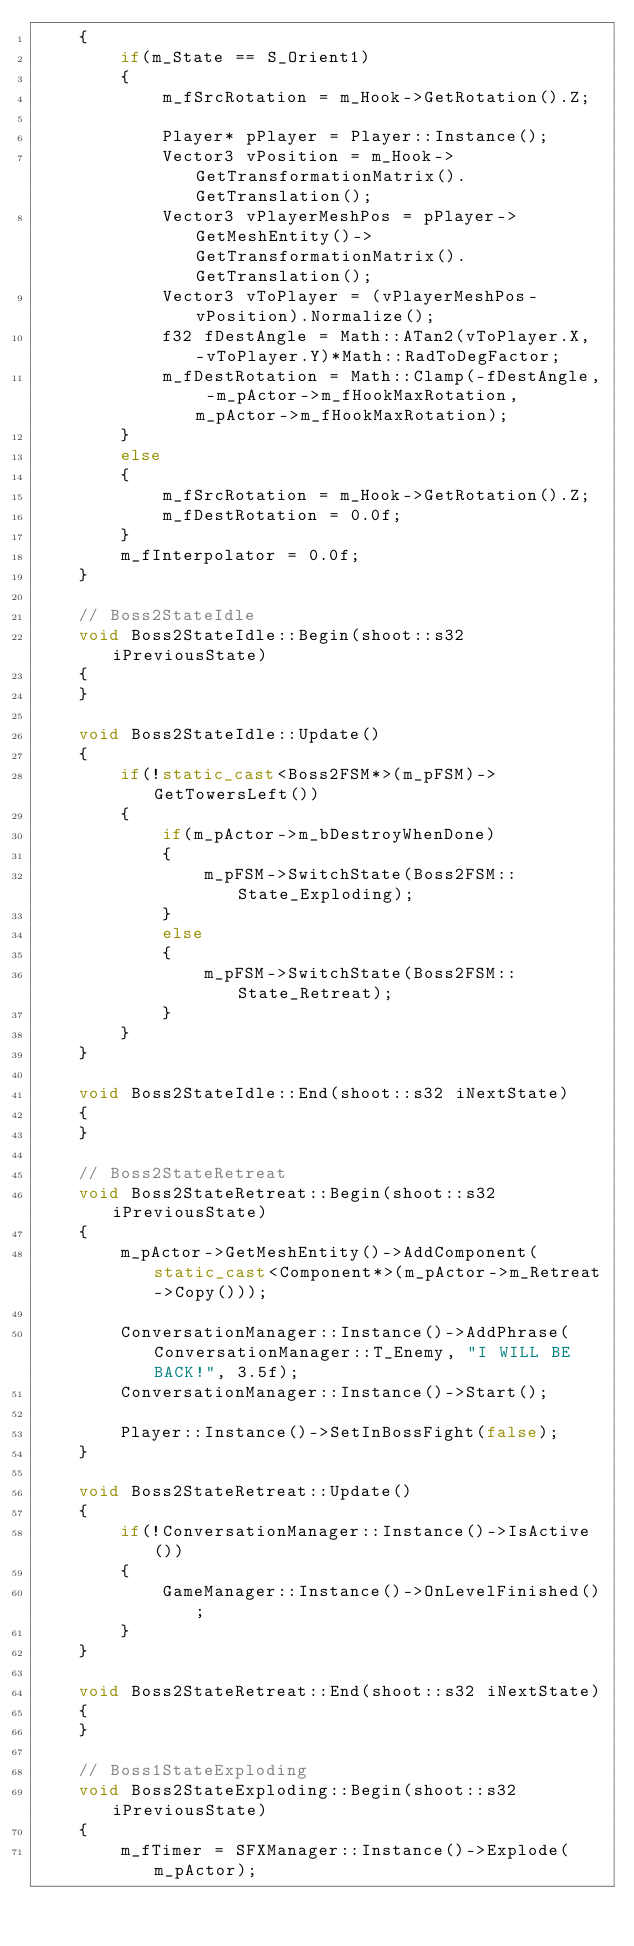Convert code to text. <code><loc_0><loc_0><loc_500><loc_500><_C++_>	{
		if(m_State == S_Orient1)
		{
			m_fSrcRotation = m_Hook->GetRotation().Z;

			Player* pPlayer = Player::Instance();
			Vector3 vPosition = m_Hook->GetTransformationMatrix().GetTranslation();			
			Vector3 vPlayerMeshPos = pPlayer->GetMeshEntity()->GetTransformationMatrix().GetTranslation();
			Vector3 vToPlayer = (vPlayerMeshPos-vPosition).Normalize();			
			f32 fDestAngle = Math::ATan2(vToPlayer.X, -vToPlayer.Y)*Math::RadToDegFactor;
			m_fDestRotation = Math::Clamp(-fDestAngle, -m_pActor->m_fHookMaxRotation, m_pActor->m_fHookMaxRotation);
		}
		else
		{
			m_fSrcRotation = m_Hook->GetRotation().Z;
			m_fDestRotation = 0.0f;
		}
		m_fInterpolator = 0.0f;
	}

	// Boss2StateIdle
	void Boss2StateIdle::Begin(shoot::s32 iPreviousState)
	{
	}

	void Boss2StateIdle::Update()
	{
		if(!static_cast<Boss2FSM*>(m_pFSM)->GetTowersLeft())
		{
			if(m_pActor->m_bDestroyWhenDone)
			{
				m_pFSM->SwitchState(Boss2FSM::State_Exploding);
			}
			else
			{
				m_pFSM->SwitchState(Boss2FSM::State_Retreat);
			}			
		}
	}

	void Boss2StateIdle::End(shoot::s32 iNextState)
	{
	}

	// Boss2StateRetreat
	void Boss2StateRetreat::Begin(shoot::s32 iPreviousState)
	{
		m_pActor->GetMeshEntity()->AddComponent(static_cast<Component*>(m_pActor->m_Retreat->Copy()));

		ConversationManager::Instance()->AddPhrase(ConversationManager::T_Enemy, "I WILL BE BACK!", 3.5f);
		ConversationManager::Instance()->Start();

		Player::Instance()->SetInBossFight(false);
	}

	void Boss2StateRetreat::Update()
	{
		if(!ConversationManager::Instance()->IsActive())
		{
			GameManager::Instance()->OnLevelFinished();
		}
	}

	void Boss2StateRetreat::End(shoot::s32 iNextState)
	{
	}

	// Boss1StateExploding
	void Boss2StateExploding::Begin(shoot::s32 iPreviousState)
	{
		m_fTimer = SFXManager::Instance()->Explode(m_pActor);
</code> 